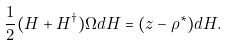<formula> <loc_0><loc_0><loc_500><loc_500>\frac { 1 } { 2 } ( H + H ^ { \dagger } ) \Omega d H = ( z - \rho ^ { * } ) d H .</formula> 